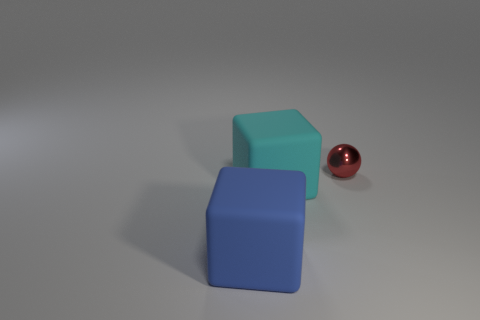Subtract all gray balls. Subtract all blue cylinders. How many balls are left? 1 Add 1 blue blocks. How many objects exist? 4 Subtract all balls. How many objects are left? 2 Add 2 tiny metal things. How many tiny metal things are left? 3 Add 1 tiny red balls. How many tiny red balls exist? 2 Subtract 0 green cylinders. How many objects are left? 3 Subtract all small red objects. Subtract all large yellow spheres. How many objects are left? 2 